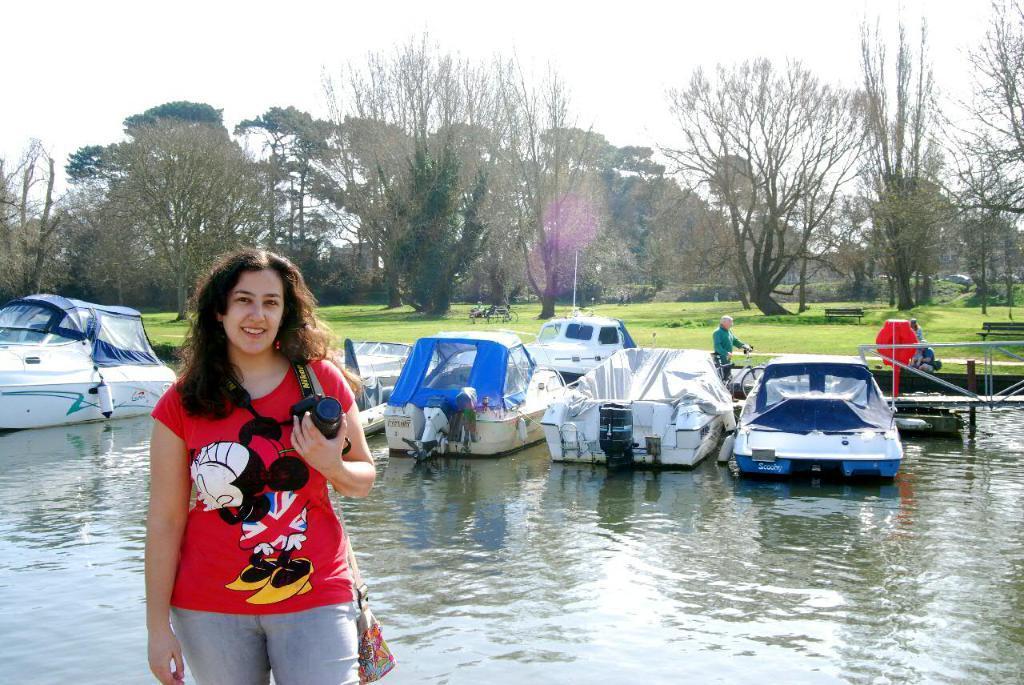How would you summarize this image in a sentence or two? In front of the image there is a woman holding a camera in her hand is standing with a smile on her face, behind the women there are a few boats in the water, on the other side of the boats there is a metal rod fence, on the other side of the fence there is a person walking with a cycle, beside the person there are a few people sitting on benches on the surface of grass, around them there are trees, in the background of the image there are houses and there are cars on the roads. 